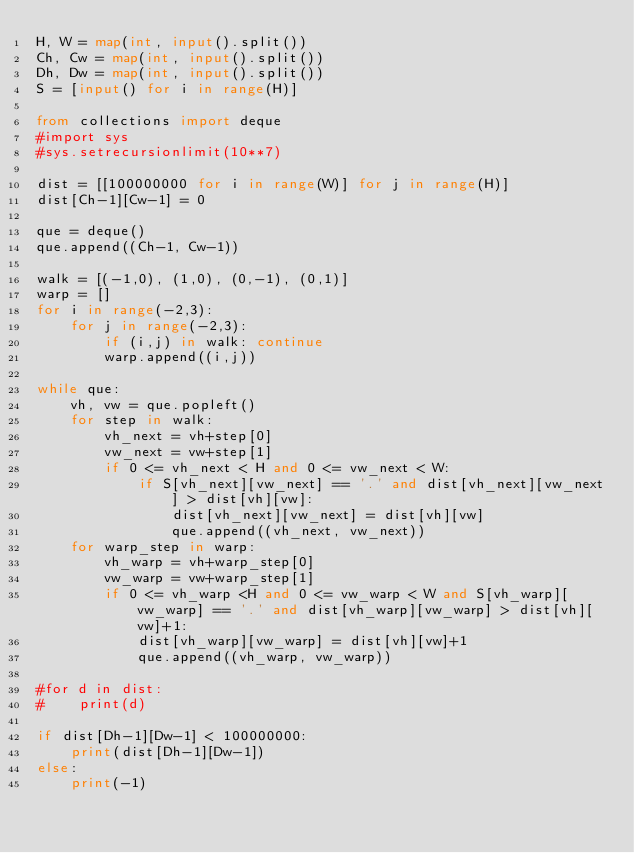Convert code to text. <code><loc_0><loc_0><loc_500><loc_500><_Python_>H, W = map(int, input().split())
Ch, Cw = map(int, input().split())
Dh, Dw = map(int, input().split())
S = [input() for i in range(H)]

from collections import deque
#import sys
#sys.setrecursionlimit(10**7)

dist = [[100000000 for i in range(W)] for j in range(H)]
dist[Ch-1][Cw-1] = 0

que = deque()
que.append((Ch-1, Cw-1))

walk = [(-1,0), (1,0), (0,-1), (0,1)]
warp = []
for i in range(-2,3):
    for j in range(-2,3):
        if (i,j) in walk: continue
        warp.append((i,j))

while que:
    vh, vw = que.popleft()
    for step in walk:
        vh_next = vh+step[0]
        vw_next = vw+step[1]
        if 0 <= vh_next < H and 0 <= vw_next < W:
            if S[vh_next][vw_next] == '.' and dist[vh_next][vw_next] > dist[vh][vw]:
                dist[vh_next][vw_next] = dist[vh][vw]
                que.append((vh_next, vw_next))
    for warp_step in warp:
        vh_warp = vh+warp_step[0]
        vw_warp = vw+warp_step[1]
        if 0 <= vh_warp <H and 0 <= vw_warp < W and S[vh_warp][vw_warp] == '.' and dist[vh_warp][vw_warp] > dist[vh][vw]+1:
            dist[vh_warp][vw_warp] = dist[vh][vw]+1
            que.append((vh_warp, vw_warp))

#for d in dist:
#    print(d)

if dist[Dh-1][Dw-1] < 100000000:
    print(dist[Dh-1][Dw-1])
else:
    print(-1)
</code> 